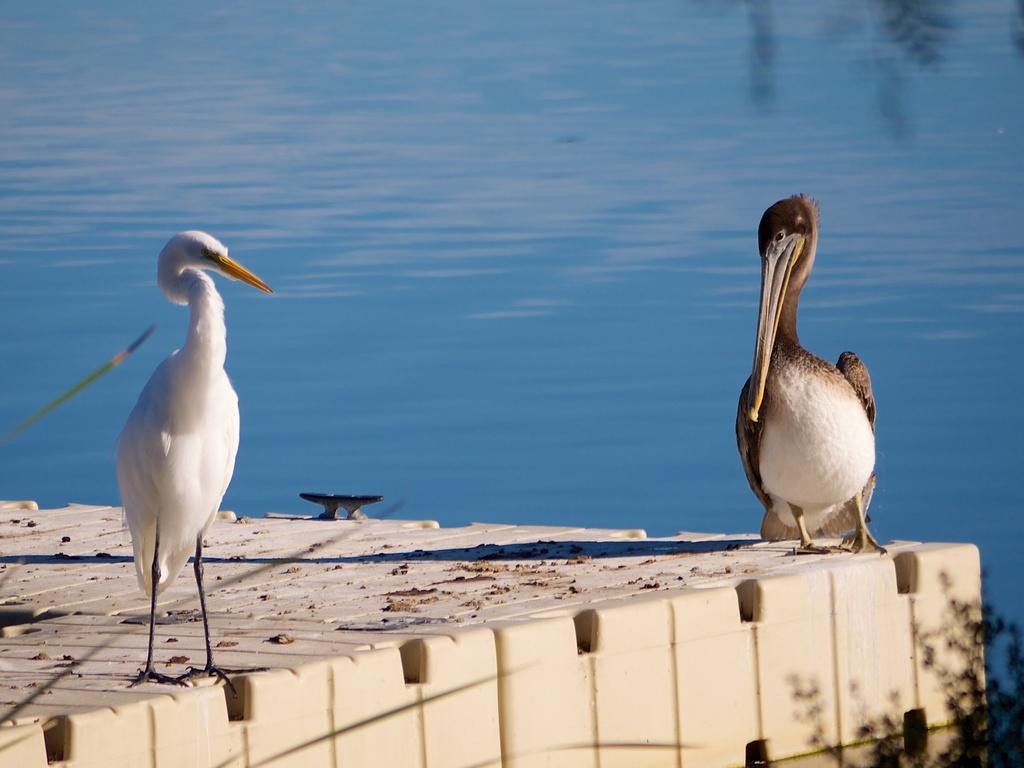Could you give a brief overview of what you see in this image? In this picture we can see two birds in the front, in the background there is water, we can see leaves of a plant at the right bottom. 